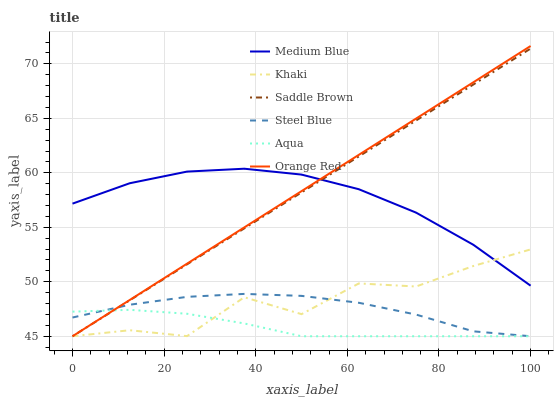Does Aqua have the minimum area under the curve?
Answer yes or no. Yes. Does Orange Red have the maximum area under the curve?
Answer yes or no. Yes. Does Medium Blue have the minimum area under the curve?
Answer yes or no. No. Does Medium Blue have the maximum area under the curve?
Answer yes or no. No. Is Saddle Brown the smoothest?
Answer yes or no. Yes. Is Khaki the roughest?
Answer yes or no. Yes. Is Medium Blue the smoothest?
Answer yes or no. No. Is Medium Blue the roughest?
Answer yes or no. No. Does Khaki have the lowest value?
Answer yes or no. Yes. Does Medium Blue have the lowest value?
Answer yes or no. No. Does Orange Red have the highest value?
Answer yes or no. Yes. Does Medium Blue have the highest value?
Answer yes or no. No. Is Aqua less than Medium Blue?
Answer yes or no. Yes. Is Medium Blue greater than Aqua?
Answer yes or no. Yes. Does Orange Red intersect Saddle Brown?
Answer yes or no. Yes. Is Orange Red less than Saddle Brown?
Answer yes or no. No. Is Orange Red greater than Saddle Brown?
Answer yes or no. No. Does Aqua intersect Medium Blue?
Answer yes or no. No. 